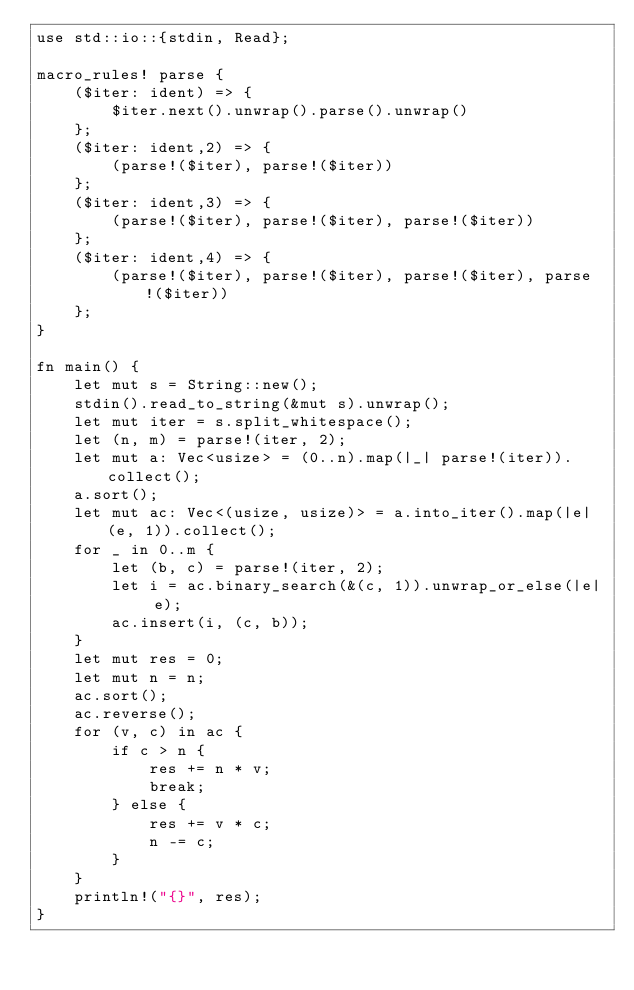Convert code to text. <code><loc_0><loc_0><loc_500><loc_500><_Rust_>use std::io::{stdin, Read};

macro_rules! parse {
    ($iter: ident) => {
        $iter.next().unwrap().parse().unwrap()
    };
    ($iter: ident,2) => {
        (parse!($iter), parse!($iter))
    };
    ($iter: ident,3) => {
        (parse!($iter), parse!($iter), parse!($iter))
    };
    ($iter: ident,4) => {
        (parse!($iter), parse!($iter), parse!($iter), parse!($iter))
    };
}

fn main() {
    let mut s = String::new();
    stdin().read_to_string(&mut s).unwrap();
    let mut iter = s.split_whitespace();
    let (n, m) = parse!(iter, 2);
    let mut a: Vec<usize> = (0..n).map(|_| parse!(iter)).collect();
    a.sort();
    let mut ac: Vec<(usize, usize)> = a.into_iter().map(|e| (e, 1)).collect();
    for _ in 0..m {
        let (b, c) = parse!(iter, 2);
        let i = ac.binary_search(&(c, 1)).unwrap_or_else(|e| e);
        ac.insert(i, (c, b));
    }
    let mut res = 0;
    let mut n = n;
    ac.sort();
    ac.reverse();
    for (v, c) in ac {
        if c > n {
            res += n * v;
            break;
        } else {
            res += v * c;
            n -= c;
        }
    }
    println!("{}", res);
}
</code> 